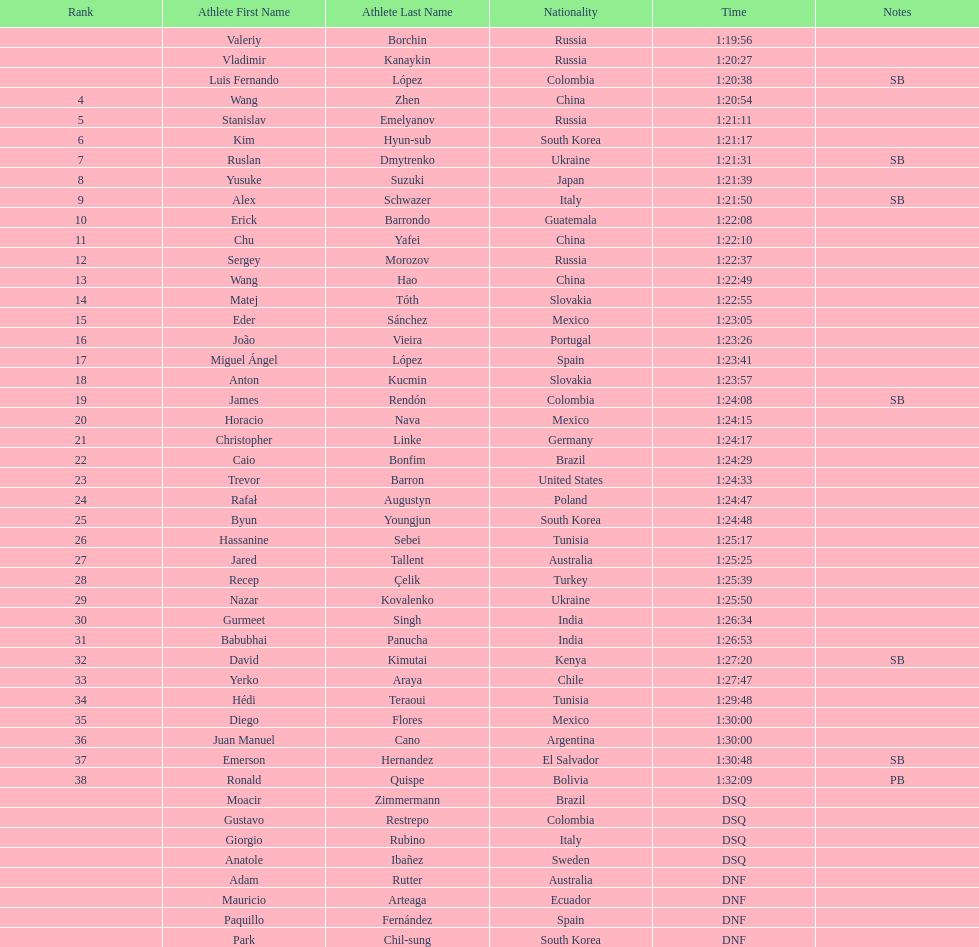What is the number of japanese in the top 10? 1. 